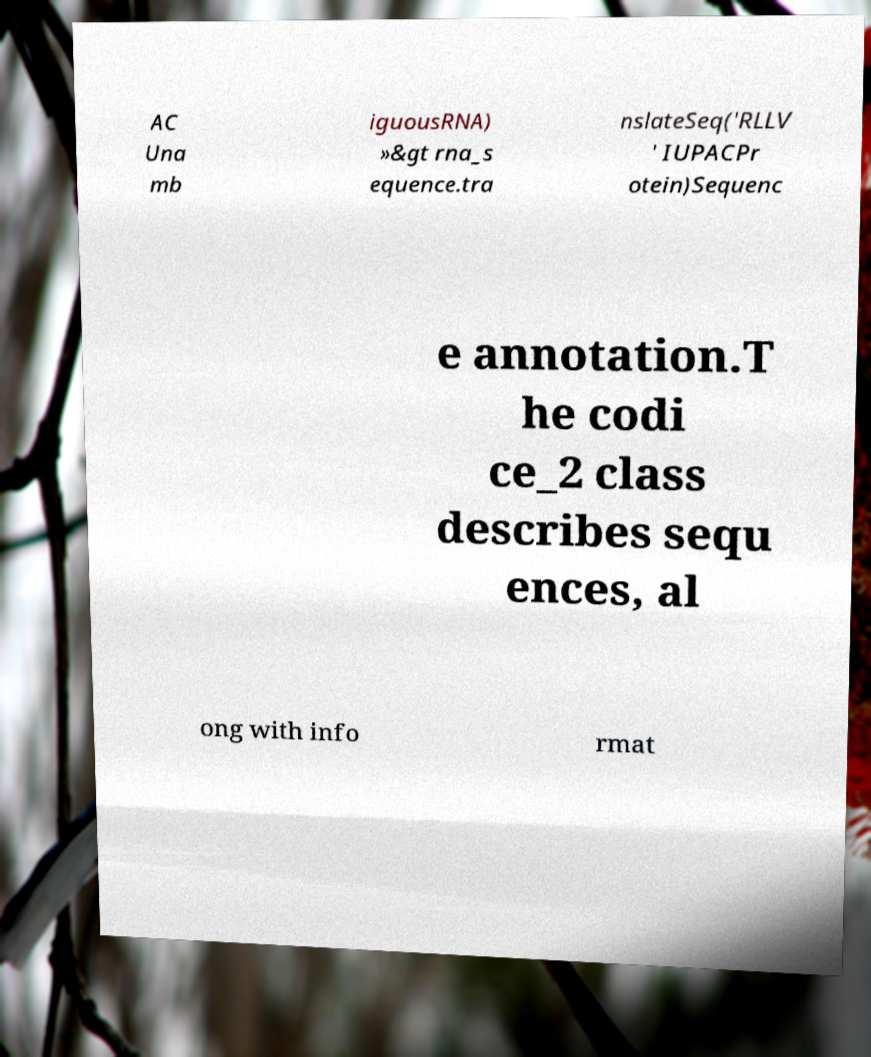Can you read and provide the text displayed in the image?This photo seems to have some interesting text. Can you extract and type it out for me? AC Una mb iguousRNA) »&gt rna_s equence.tra nslateSeq('RLLV ' IUPACPr otein)Sequenc e annotation.T he codi ce_2 class describes sequ ences, al ong with info rmat 